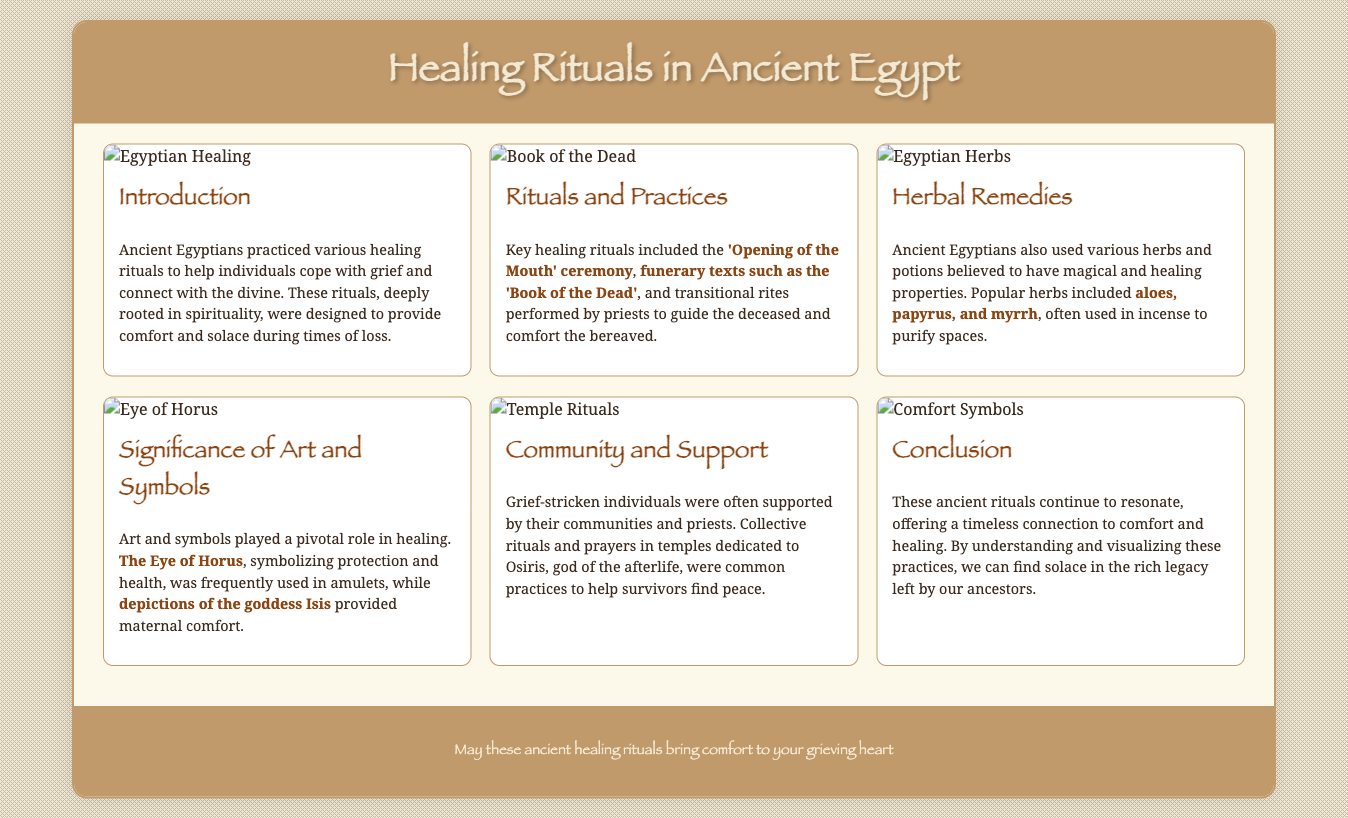what is the main theme of the presentation? The presentation focuses on ancient Egypt's healing rituals and their significance in providing comfort to grief-stricken individuals.
Answer: healing rituals what ceremony is mentioned for providing solace? The presentation highlights the 'Opening of the Mouth' ceremony as a key healing ritual.
Answer: 'Opening of the Mouth' which text is associated with funerary practices? The 'Book of the Dead' is referenced in the document as part of the healing rituals.
Answer: 'Book of the Dead' what herb is noted for its use in ancient Egyptian healing? The document mentions aloes, papyrus, and myrrh as popular herbs in healing practices.
Answer: myrrh who is the god associated with afterlife rituals in the community? Osiris is the god referred to in the context of community support and rituals for healing.
Answer: Osiris what role do symbols play in the healing process? Art and symbols, such as the Eye of Horus, are significant in the healing rituals and provide protection and health.
Answer: protection how do communities contribute to healing rituals? The document states that guilt-stricken individuals received support through collective rituals and prayers.
Answer: collective rituals what is the concluding message of the presentation? The conclusion emphasizes finding solace from ancient rituals that connect to comfort and healing.
Answer: comfort 